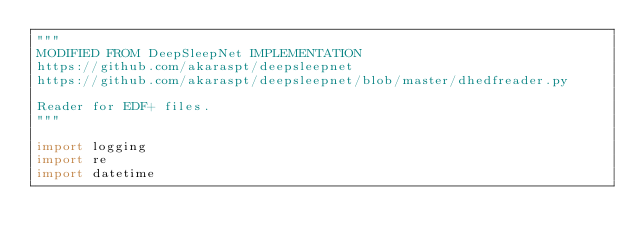Convert code to text. <code><loc_0><loc_0><loc_500><loc_500><_Python_>"""
MODIFIED FROM DeepSleepNet IMPLEMENTATION
https://github.com/akaraspt/deepsleepnet
https://github.com/akaraspt/deepsleepnet/blob/master/dhedfreader.py

Reader for EDF+ files.
"""

import logging
import re
import datetime</code> 